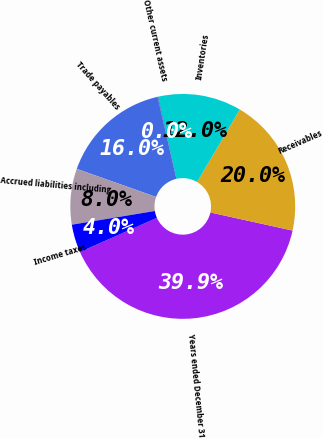Convert chart. <chart><loc_0><loc_0><loc_500><loc_500><pie_chart><fcel>Years ended December 31<fcel>Receivables<fcel>Inventories<fcel>Other current assets<fcel>Trade payables<fcel>Accrued liabilities including<fcel>Income taxes<nl><fcel>39.91%<fcel>19.98%<fcel>12.01%<fcel>0.05%<fcel>15.99%<fcel>8.02%<fcel>4.04%<nl></chart> 